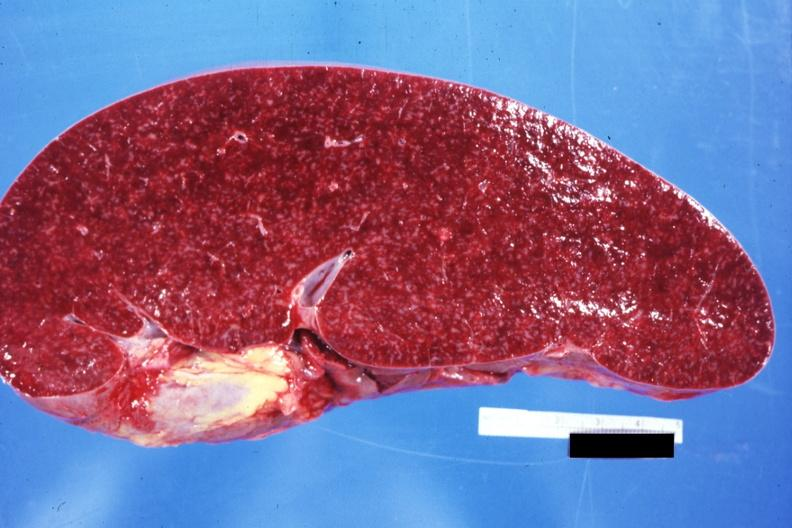s hematologic present?
Answer the question using a single word or phrase. Yes 